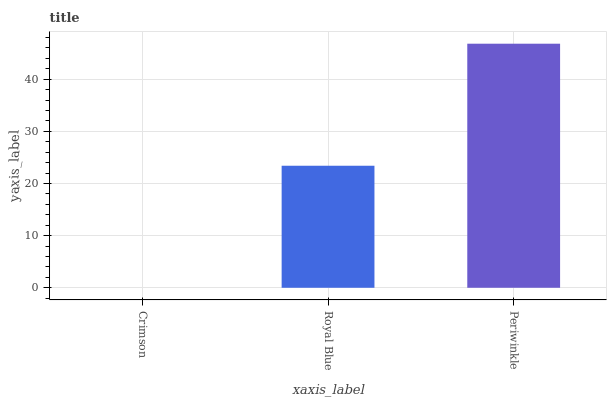Is Crimson the minimum?
Answer yes or no. Yes. Is Periwinkle the maximum?
Answer yes or no. Yes. Is Royal Blue the minimum?
Answer yes or no. No. Is Royal Blue the maximum?
Answer yes or no. No. Is Royal Blue greater than Crimson?
Answer yes or no. Yes. Is Crimson less than Royal Blue?
Answer yes or no. Yes. Is Crimson greater than Royal Blue?
Answer yes or no. No. Is Royal Blue less than Crimson?
Answer yes or no. No. Is Royal Blue the high median?
Answer yes or no. Yes. Is Royal Blue the low median?
Answer yes or no. Yes. Is Crimson the high median?
Answer yes or no. No. Is Periwinkle the low median?
Answer yes or no. No. 